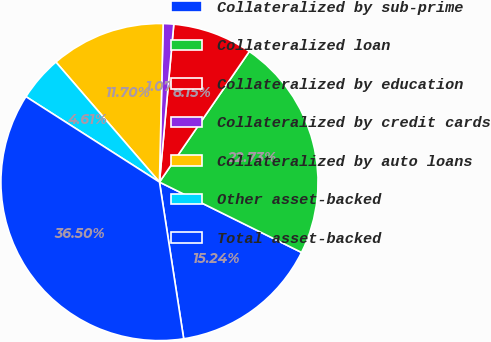<chart> <loc_0><loc_0><loc_500><loc_500><pie_chart><fcel>Collateralized by sub-prime<fcel>Collateralized loan<fcel>Collateralized by education<fcel>Collateralized by credit cards<fcel>Collateralized by auto loans<fcel>Other asset-backed<fcel>Total asset-backed<nl><fcel>15.24%<fcel>22.73%<fcel>8.15%<fcel>1.07%<fcel>11.7%<fcel>4.61%<fcel>36.5%<nl></chart> 